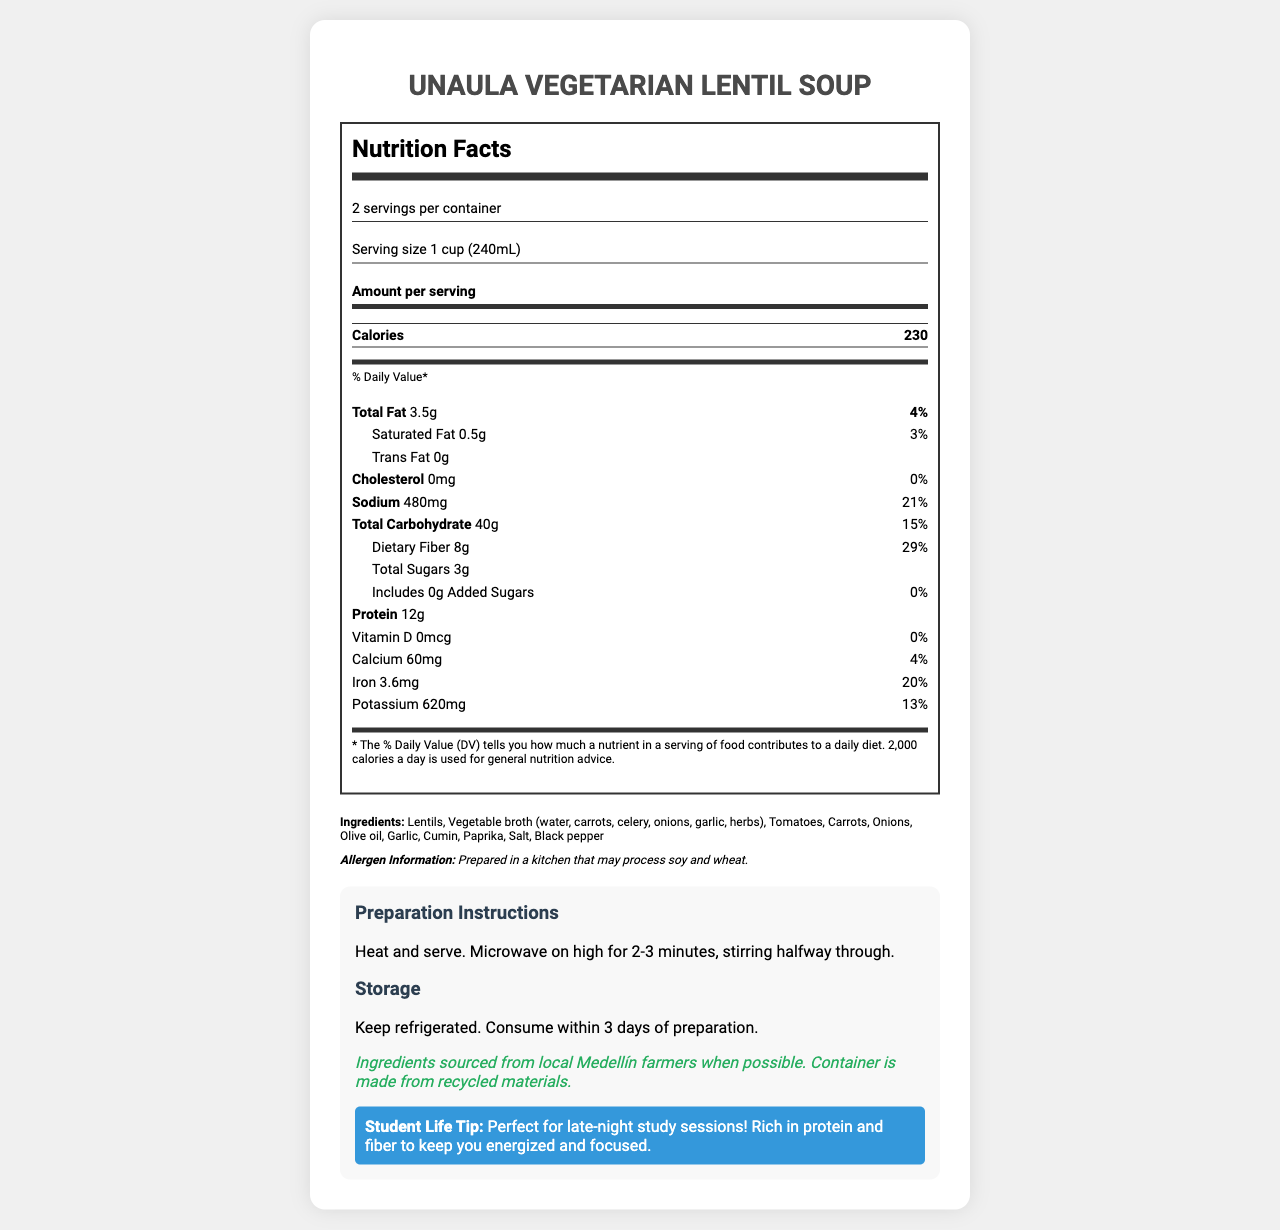what is the serving size of the vegetarian lentil soup? The serving size is clearly mentioned in the document as "1 cup (240mL)".
Answer: 1 cup (240mL) how many servings are in one container of the soup? The document states that there are 2 servings per container.
Answer: 2 what is the amount of protein per serving? According to the nutrition facts, each serving contains 12 grams of protein.
Answer: 12g what is the total fat content per serving? The nutrition label specifies that the total fat content per serving is 3.5 grams.
Answer: 3.5g how much dietary fiber is in each serving? The document lists the dietary fiber content per serving as 8 grams.
Answer: 8g how much iron does one serving of the soup provide? A. 3.6mg B. 2.5mg C. 4mg The document states that one serving of the soup provides 3.6mg of iron.
Answer: A. 3.6mg what is the daily value percentage of sodium in one serving? A. 15% B. 21% C. 29% D. 40% The daily value percentage for sodium per serving is listed as 21%.
Answer: B. 21% what kind of broth is used in the soup? The ingredients section mentions vegetable broth made from water, carrots, celery, onions, garlic, and herbs.
Answer: Vegetable broth Is the soup appropriate for people with soy or wheat allergies? The allergen information states that it is prepared in a kitchen that may process soy and wheat.
Answer: No is there any added sugar in the soup? The document mentions that the soup has 0 grams of added sugars.
Answer: No describe the main idea of the document The document details various aspects of the UNAULA Vegetarian Lentil Soup, such as nutritional content per serving, ingredients, allergen info, how to prepare and store the soup, sustainability efforts, and tips for students.
Answer: The document provides the nutrition facts for UNAULA Vegetarian Lentil Soup, including details about serving size, calories, and the nutritional content per serving. It also lists the ingredients, allergen information, preparation instructions, storage guidelines, and additional notes on sustainability and student life tips. how long should you microwave the soup for preparation? The preparation instructions say to microwave the soup on high for 2-3 minutes, stirring halfway through.
Answer: 2-3 minutes what is the container made from? The sustainability note mentions that the container is made from recycled materials.
Answer: Recycled materials what is the main source of protein in the soup? Although not explicitly stated, it is reasonable to infer that lentils, being a primary ingredient and a known protein source, are the main source of protein.
Answer: Lentils how many calories are in one serving of the soup? The document states that each serving of the soup contains 230 calories.
Answer: 230 what type of information is listed under "extra-info"? The "extra-info" section of the document includes preparation instructions, storage guidelines, a sustainability note, and a student life tip.
Answer: Preparation instructions, storage, sustainability note, student life tip how many grams of total carbohydrate are in one serving? The total carbohydrate content per serving is listed as 40 grams.
Answer: 40g can you determine the cooking method for the soup? The document provides preparation instructions for heating the soup but does not detail the initial cooking method used to prepare it.
Answer: Not enough information 